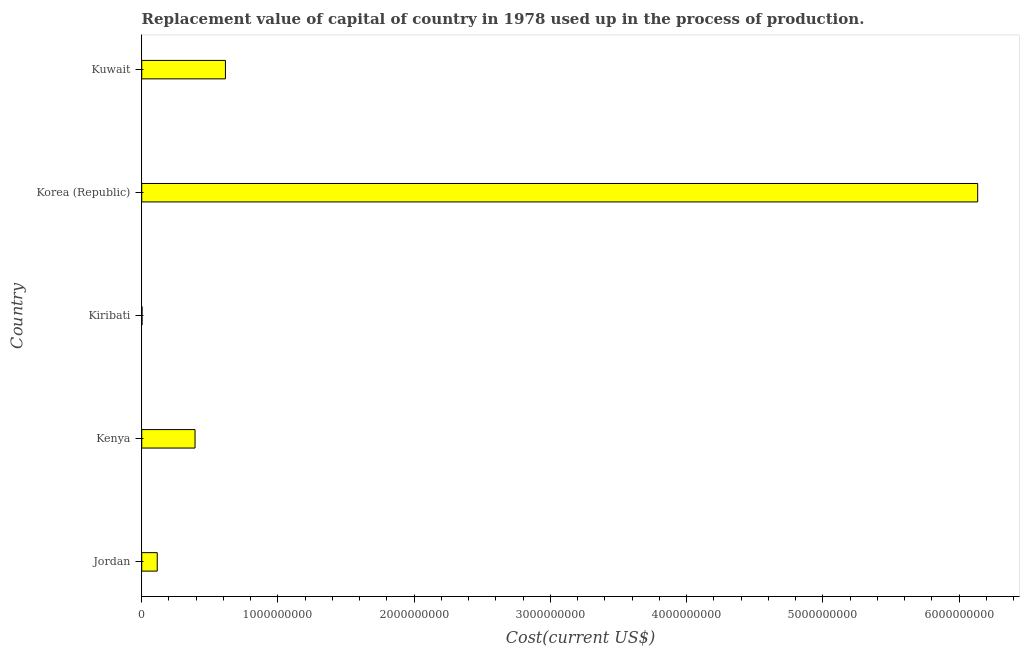What is the title of the graph?
Provide a succinct answer. Replacement value of capital of country in 1978 used up in the process of production. What is the label or title of the X-axis?
Your answer should be compact. Cost(current US$). What is the consumption of fixed capital in Kuwait?
Provide a short and direct response. 6.14e+08. Across all countries, what is the maximum consumption of fixed capital?
Make the answer very short. 6.14e+09. Across all countries, what is the minimum consumption of fixed capital?
Your answer should be compact. 2.48e+06. In which country was the consumption of fixed capital maximum?
Give a very brief answer. Korea (Republic). In which country was the consumption of fixed capital minimum?
Make the answer very short. Kiribati. What is the sum of the consumption of fixed capital?
Provide a short and direct response. 7.26e+09. What is the difference between the consumption of fixed capital in Kiribati and Kuwait?
Give a very brief answer. -6.12e+08. What is the average consumption of fixed capital per country?
Make the answer very short. 1.45e+09. What is the median consumption of fixed capital?
Offer a very short reply. 3.91e+08. In how many countries, is the consumption of fixed capital greater than 2200000000 US$?
Provide a short and direct response. 1. What is the ratio of the consumption of fixed capital in Kenya to that in Kiribati?
Your answer should be very brief. 158.08. Is the difference between the consumption of fixed capital in Jordan and Kenya greater than the difference between any two countries?
Ensure brevity in your answer.  No. What is the difference between the highest and the second highest consumption of fixed capital?
Your response must be concise. 5.52e+09. What is the difference between the highest and the lowest consumption of fixed capital?
Offer a very short reply. 6.13e+09. Are the values on the major ticks of X-axis written in scientific E-notation?
Give a very brief answer. No. What is the Cost(current US$) of Jordan?
Your answer should be very brief. 1.14e+08. What is the Cost(current US$) of Kenya?
Keep it short and to the point. 3.91e+08. What is the Cost(current US$) in Kiribati?
Offer a terse response. 2.48e+06. What is the Cost(current US$) in Korea (Republic)?
Make the answer very short. 6.14e+09. What is the Cost(current US$) of Kuwait?
Your response must be concise. 6.14e+08. What is the difference between the Cost(current US$) in Jordan and Kenya?
Offer a terse response. -2.77e+08. What is the difference between the Cost(current US$) in Jordan and Kiribati?
Provide a succinct answer. 1.11e+08. What is the difference between the Cost(current US$) in Jordan and Korea (Republic)?
Offer a terse response. -6.02e+09. What is the difference between the Cost(current US$) in Jordan and Kuwait?
Your response must be concise. -5.01e+08. What is the difference between the Cost(current US$) in Kenya and Kiribati?
Offer a terse response. 3.89e+08. What is the difference between the Cost(current US$) in Kenya and Korea (Republic)?
Provide a short and direct response. -5.74e+09. What is the difference between the Cost(current US$) in Kenya and Kuwait?
Ensure brevity in your answer.  -2.23e+08. What is the difference between the Cost(current US$) in Kiribati and Korea (Republic)?
Offer a terse response. -6.13e+09. What is the difference between the Cost(current US$) in Kiribati and Kuwait?
Keep it short and to the point. -6.12e+08. What is the difference between the Cost(current US$) in Korea (Republic) and Kuwait?
Your answer should be very brief. 5.52e+09. What is the ratio of the Cost(current US$) in Jordan to that in Kenya?
Offer a very short reply. 0.29. What is the ratio of the Cost(current US$) in Jordan to that in Kiribati?
Your response must be concise. 45.99. What is the ratio of the Cost(current US$) in Jordan to that in Korea (Republic)?
Your answer should be compact. 0.02. What is the ratio of the Cost(current US$) in Jordan to that in Kuwait?
Keep it short and to the point. 0.18. What is the ratio of the Cost(current US$) in Kenya to that in Kiribati?
Provide a succinct answer. 158.08. What is the ratio of the Cost(current US$) in Kenya to that in Korea (Republic)?
Your answer should be compact. 0.06. What is the ratio of the Cost(current US$) in Kenya to that in Kuwait?
Provide a short and direct response. 0.64. What is the ratio of the Cost(current US$) in Kiribati to that in Kuwait?
Keep it short and to the point. 0. What is the ratio of the Cost(current US$) in Korea (Republic) to that in Kuwait?
Your answer should be very brief. 9.99. 